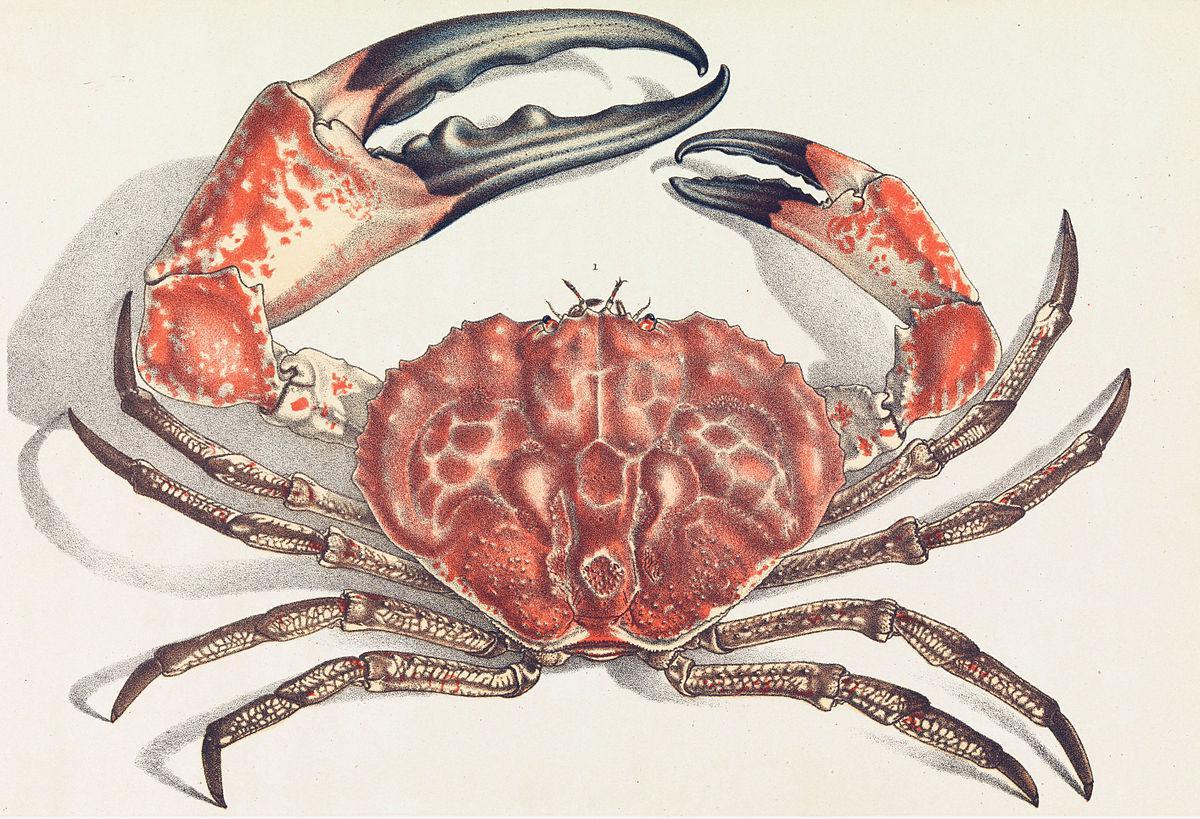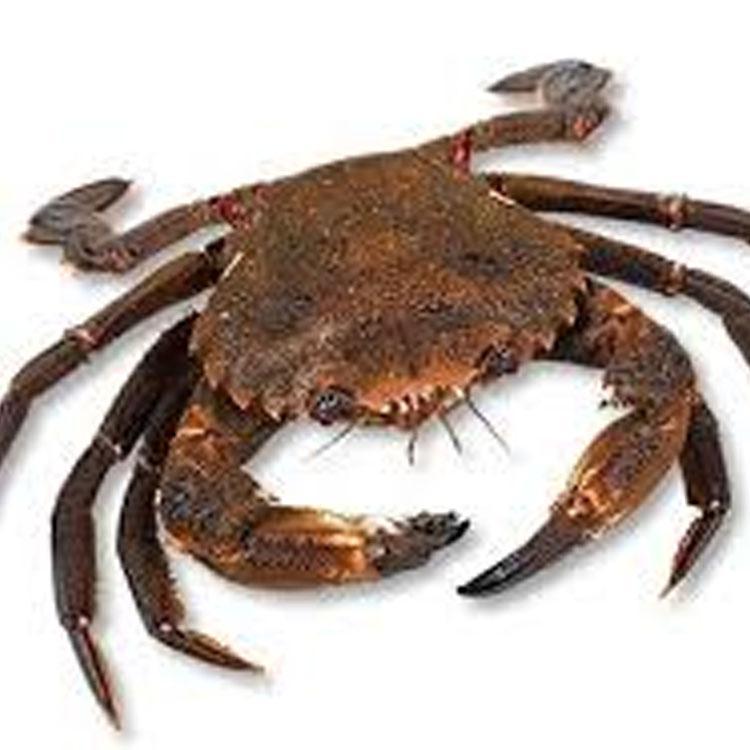The first image is the image on the left, the second image is the image on the right. For the images displayed, is the sentence "The left image contains a shell-up crab with its face at the top and its front claws above its head and both pointing inward." factually correct? Answer yes or no. Yes. The first image is the image on the left, the second image is the image on the right. Considering the images on both sides, is "The left and right image contains the same number of crabs with at least one with blue claws." valid? Answer yes or no. No. 